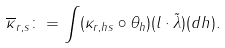Convert formula to latex. <formula><loc_0><loc_0><loc_500><loc_500>\overline { \kappa } _ { r , s } \colon = \int ( \kappa _ { r , h s } \circ \theta _ { h } ) ( l \cdot \tilde { \lambda } ) ( d h ) .</formula> 